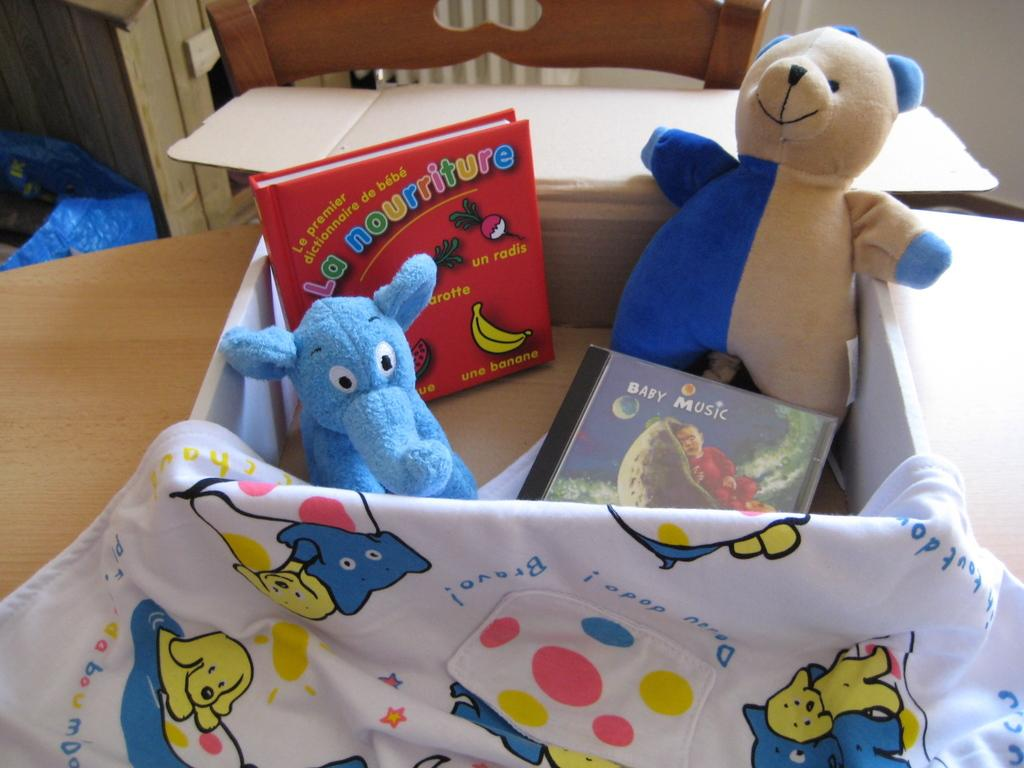What is located in the foreground of the picture? There is a desk, a towel, and a box in the foreground of the picture. What is inside the box? The box contains books and toys. What type of furniture is present in the picture? There is a chair in the picture. What is covering something in the picture? There is a cover in the picture. What is visible in the background of the picture? There is a wall in the picture. What material is the wooden object made of? There is a wooden object in the picture. How many prisoners are visible in the picture? There are no prisoners present in the picture; it features a desk, towel, box, chair, cover, wall, and a wooden object. What type of lipstick is being used by the person in the picture? There is no person or lipstick present in the picture. 